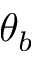<formula> <loc_0><loc_0><loc_500><loc_500>\theta _ { b }</formula> 